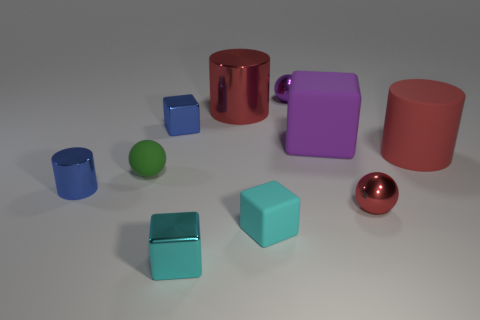There is a cylinder that is the same size as the green matte sphere; what is its color?
Your response must be concise. Blue. Does the big rubber cylinder have the same color as the large object that is behind the big purple object?
Offer a very short reply. Yes. The tiny shiny cylinder is what color?
Ensure brevity in your answer.  Blue. There is a red cylinder in front of the big purple matte cube; what is it made of?
Your answer should be very brief. Rubber. What size is the purple metal thing that is the same shape as the tiny green matte object?
Ensure brevity in your answer.  Small. Is the number of small purple objects that are on the left side of the cyan metal cube less than the number of blue shiny things?
Offer a very short reply. Yes. Are there any large red matte blocks?
Provide a succinct answer. No. There is another rubber thing that is the same shape as the large purple rubber thing; what color is it?
Give a very brief answer. Cyan. Do the cube to the left of the cyan metal thing and the small cylinder have the same color?
Keep it short and to the point. Yes. Does the purple metal object have the same size as the red sphere?
Provide a short and direct response. Yes. 